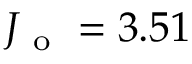Convert formula to latex. <formula><loc_0><loc_0><loc_500><loc_500>J _ { o } = 3 . 5 1</formula> 